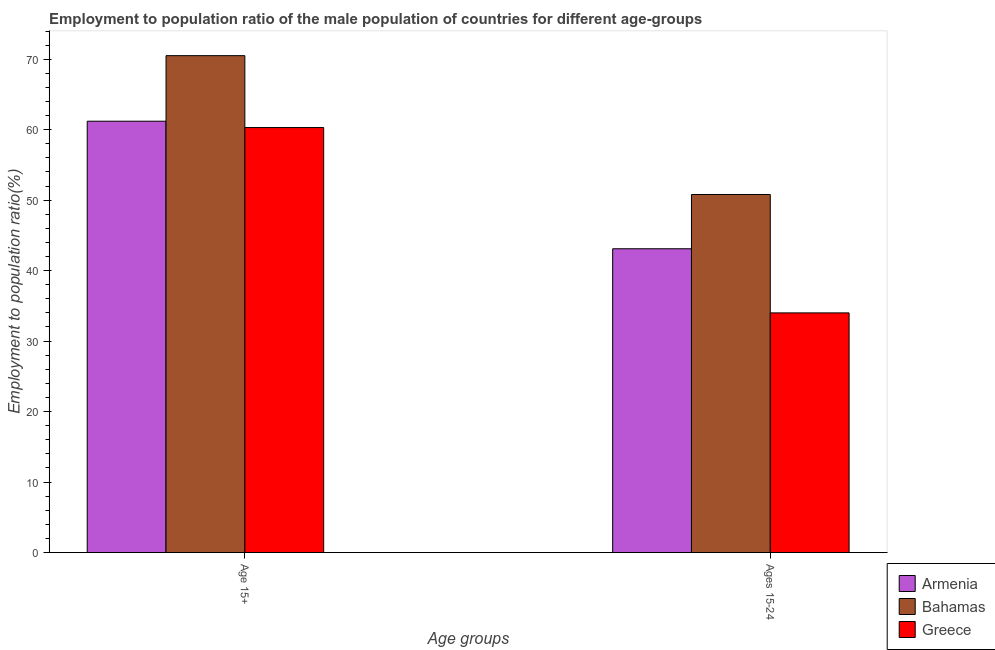How many different coloured bars are there?
Keep it short and to the point. 3. How many bars are there on the 2nd tick from the right?
Provide a short and direct response. 3. What is the label of the 2nd group of bars from the left?
Offer a terse response. Ages 15-24. What is the employment to population ratio(age 15-24) in Greece?
Your answer should be compact. 34. Across all countries, what is the maximum employment to population ratio(age 15-24)?
Provide a short and direct response. 50.8. Across all countries, what is the minimum employment to population ratio(age 15+)?
Give a very brief answer. 60.3. In which country was the employment to population ratio(age 15+) maximum?
Your answer should be very brief. Bahamas. What is the total employment to population ratio(age 15-24) in the graph?
Offer a very short reply. 127.9. What is the difference between the employment to population ratio(age 15+) in Bahamas and that in Greece?
Provide a succinct answer. 10.2. What is the difference between the employment to population ratio(age 15+) in Greece and the employment to population ratio(age 15-24) in Bahamas?
Provide a short and direct response. 9.5. What is the average employment to population ratio(age 15+) per country?
Give a very brief answer. 64. What is the difference between the employment to population ratio(age 15-24) and employment to population ratio(age 15+) in Greece?
Provide a succinct answer. -26.3. In how many countries, is the employment to population ratio(age 15+) greater than 62 %?
Give a very brief answer. 1. What is the ratio of the employment to population ratio(age 15-24) in Armenia to that in Greece?
Give a very brief answer. 1.27. Is the employment to population ratio(age 15+) in Greece less than that in Bahamas?
Ensure brevity in your answer.  Yes. What does the 2nd bar from the right in Ages 15-24 represents?
Your response must be concise. Bahamas. How many bars are there?
Give a very brief answer. 6. Are all the bars in the graph horizontal?
Provide a short and direct response. No. How many countries are there in the graph?
Your response must be concise. 3. What is the difference between two consecutive major ticks on the Y-axis?
Your answer should be very brief. 10. Does the graph contain any zero values?
Make the answer very short. No. Where does the legend appear in the graph?
Your answer should be compact. Bottom right. What is the title of the graph?
Provide a short and direct response. Employment to population ratio of the male population of countries for different age-groups. What is the label or title of the X-axis?
Provide a short and direct response. Age groups. What is the Employment to population ratio(%) of Armenia in Age 15+?
Your response must be concise. 61.2. What is the Employment to population ratio(%) in Bahamas in Age 15+?
Your response must be concise. 70.5. What is the Employment to population ratio(%) in Greece in Age 15+?
Keep it short and to the point. 60.3. What is the Employment to population ratio(%) in Armenia in Ages 15-24?
Provide a short and direct response. 43.1. What is the Employment to population ratio(%) in Bahamas in Ages 15-24?
Ensure brevity in your answer.  50.8. What is the Employment to population ratio(%) of Greece in Ages 15-24?
Provide a succinct answer. 34. Across all Age groups, what is the maximum Employment to population ratio(%) of Armenia?
Ensure brevity in your answer.  61.2. Across all Age groups, what is the maximum Employment to population ratio(%) of Bahamas?
Your response must be concise. 70.5. Across all Age groups, what is the maximum Employment to population ratio(%) in Greece?
Make the answer very short. 60.3. Across all Age groups, what is the minimum Employment to population ratio(%) in Armenia?
Make the answer very short. 43.1. Across all Age groups, what is the minimum Employment to population ratio(%) of Bahamas?
Provide a succinct answer. 50.8. What is the total Employment to population ratio(%) of Armenia in the graph?
Provide a succinct answer. 104.3. What is the total Employment to population ratio(%) in Bahamas in the graph?
Provide a succinct answer. 121.3. What is the total Employment to population ratio(%) in Greece in the graph?
Ensure brevity in your answer.  94.3. What is the difference between the Employment to population ratio(%) in Greece in Age 15+ and that in Ages 15-24?
Offer a terse response. 26.3. What is the difference between the Employment to population ratio(%) in Armenia in Age 15+ and the Employment to population ratio(%) in Bahamas in Ages 15-24?
Offer a very short reply. 10.4. What is the difference between the Employment to population ratio(%) in Armenia in Age 15+ and the Employment to population ratio(%) in Greece in Ages 15-24?
Offer a terse response. 27.2. What is the difference between the Employment to population ratio(%) of Bahamas in Age 15+ and the Employment to population ratio(%) of Greece in Ages 15-24?
Keep it short and to the point. 36.5. What is the average Employment to population ratio(%) of Armenia per Age groups?
Give a very brief answer. 52.15. What is the average Employment to population ratio(%) in Bahamas per Age groups?
Offer a very short reply. 60.65. What is the average Employment to population ratio(%) in Greece per Age groups?
Provide a short and direct response. 47.15. What is the difference between the Employment to population ratio(%) in Armenia and Employment to population ratio(%) in Bahamas in Age 15+?
Give a very brief answer. -9.3. What is the difference between the Employment to population ratio(%) in Armenia and Employment to population ratio(%) in Bahamas in Ages 15-24?
Offer a very short reply. -7.7. What is the difference between the Employment to population ratio(%) of Armenia and Employment to population ratio(%) of Greece in Ages 15-24?
Give a very brief answer. 9.1. What is the ratio of the Employment to population ratio(%) in Armenia in Age 15+ to that in Ages 15-24?
Your response must be concise. 1.42. What is the ratio of the Employment to population ratio(%) of Bahamas in Age 15+ to that in Ages 15-24?
Offer a very short reply. 1.39. What is the ratio of the Employment to population ratio(%) of Greece in Age 15+ to that in Ages 15-24?
Provide a short and direct response. 1.77. What is the difference between the highest and the second highest Employment to population ratio(%) in Armenia?
Offer a very short reply. 18.1. What is the difference between the highest and the second highest Employment to population ratio(%) of Bahamas?
Provide a succinct answer. 19.7. What is the difference between the highest and the second highest Employment to population ratio(%) in Greece?
Ensure brevity in your answer.  26.3. What is the difference between the highest and the lowest Employment to population ratio(%) in Greece?
Your answer should be very brief. 26.3. 